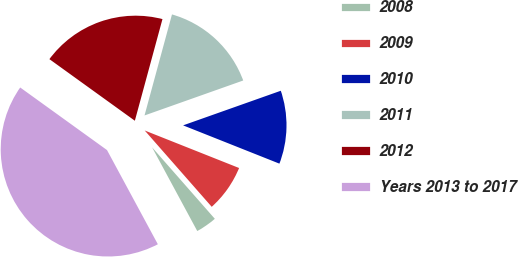Convert chart to OTSL. <chart><loc_0><loc_0><loc_500><loc_500><pie_chart><fcel>2008<fcel>2009<fcel>2010<fcel>2011<fcel>2012<fcel>Years 2013 to 2017<nl><fcel>3.59%<fcel>7.51%<fcel>11.44%<fcel>15.36%<fcel>19.28%<fcel>42.82%<nl></chart> 